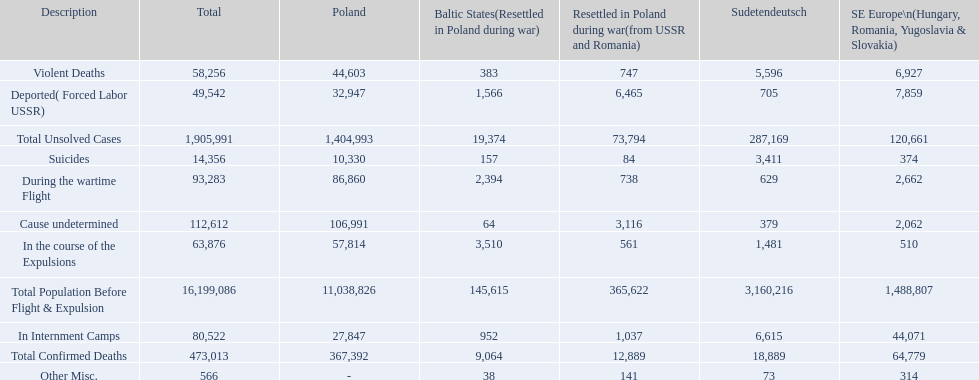How many deaths did the baltic states have in each category? 145,615, 383, 157, 1,566, 952, 2,394, 3,510, 64, 38, 9,064, 19,374. How many cause undetermined deaths did baltic states have? 64. How many other miscellaneous deaths did baltic states have? 38. Which is higher in deaths, cause undetermined or other miscellaneous? Cause undetermined. 